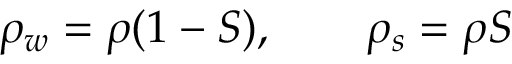<formula> <loc_0><loc_0><loc_500><loc_500>\rho _ { w } = \rho ( 1 - S ) , \quad \rho _ { s } = \rho S</formula> 